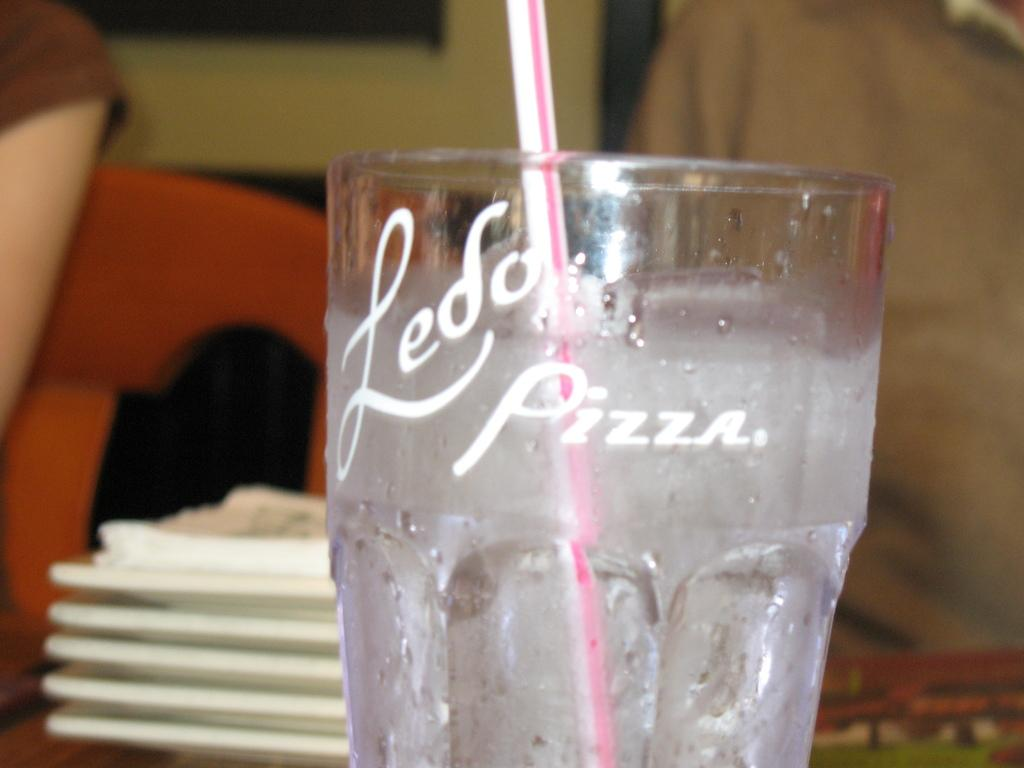<image>
Offer a succinct explanation of the picture presented. Straw in a cup of water that says Ledo Pizza on it. 